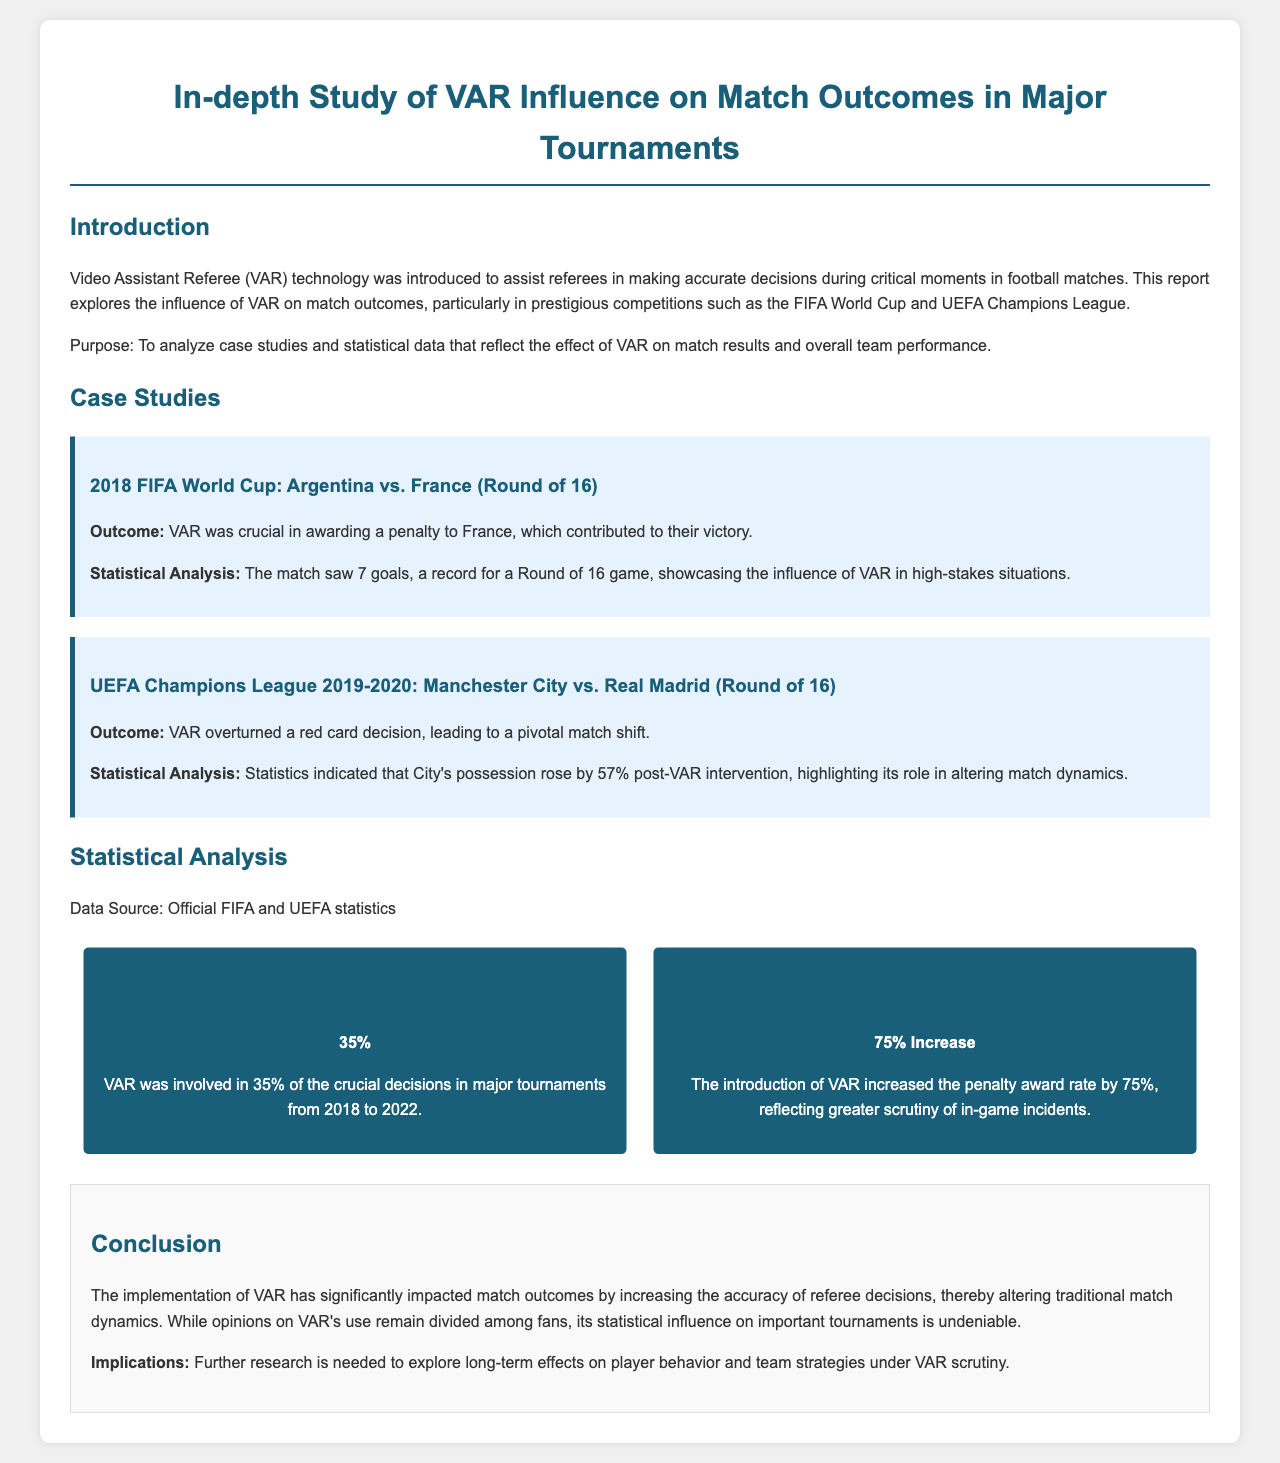What was the outcome of the 2018 FIFA World Cup match between Argentina and France? The outcome was that VAR was crucial in awarding a penalty to France, which contributed to their victory.
Answer: Penalty to France What percentage of crucial decisions involved VAR from 2018 to 2022? The document states that VAR was involved in 35% of crucial decisions in major tournaments.
Answer: 35% What was the penalty award rate increase after the introduction of VAR? The document mentions a 75% increase in the penalty award rate due to VAR.
Answer: 75% Increase How did Manchester City's possession change post-VAR intervention in the Champions League match against Real Madrid? The statistics indicated that City's possession rose by 57% after the VAR intervention.
Answer: 57% What is the main implication mentioned in the conclusion regarding VAR? The conclusion states that further research is needed to explore long-term effects on player behavior and team strategies under VAR scrutiny.
Answer: Further research needed What tournaments were specifically analyzed in this report? The report focuses on prestigious competitions such as the FIFA World Cup and UEFA Champions League.
Answer: FIFA World Cup and UEFA Champions League What was the main purpose of this report? The purpose was to analyze case studies and statistical data reflecting the effect of VAR on match results and overall team performance.
Answer: Analyze case studies and statistical data What year was the UEFA Champions League match between Manchester City and Real Madrid? The match took place in the 2019-2020 tournament season.
Answer: 2019-2020 